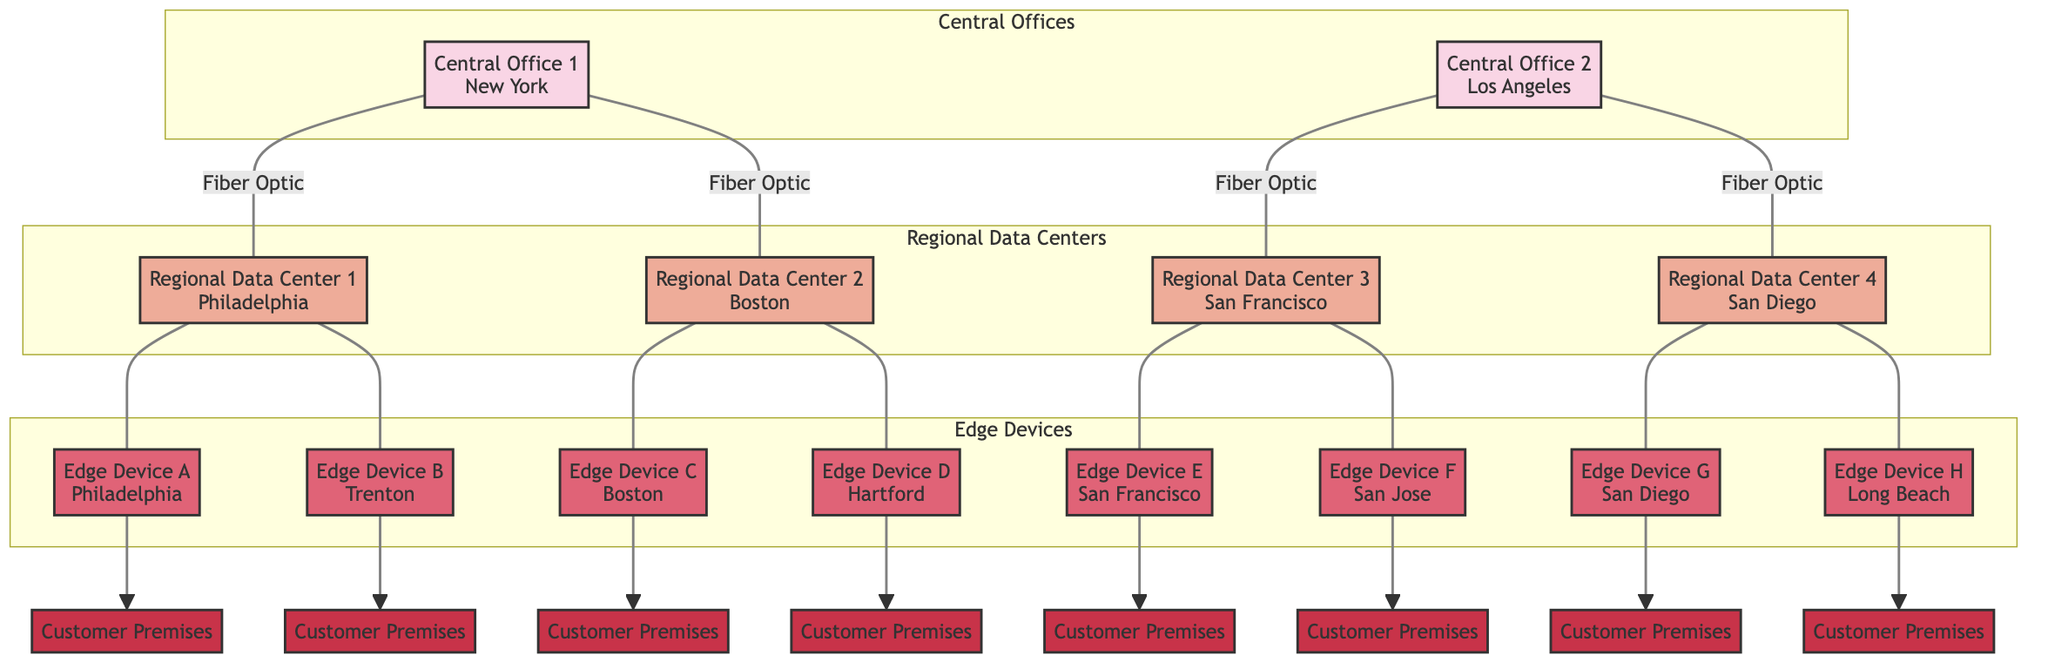What is the role of Central Office 1? According to the diagram, Central Office 1 is defined as the "Main data aggregation and routing hub." This comes directly from the descriptive labels in the nodes.
Answer: Main data aggregation and routing hub How many regional data centers are connected to Central Office 2? By examining the connections from Central Office 2 in the diagram, we see it is linked to two regional data centers: Regional Data Center 3 and Regional Data Center 4. Thus, the count is two.
Answer: 2 Which edge device is located in Boston? The diagram specifies that Edge Device C is in Boston. This information can be found by looking at the location attributes assigned to each edge device in their respective nodes.
Answer: Edge Device C What type of connection is used between Central Office 1 and Regional Data Center 1? The connection type between Central Office 1 and Regional Data Center 1 is labeled as "Fiber Optic" in the diagram, which is noted in the edges connecting the nodes.
Answer: Fiber Optic How many edge devices are connected to Regional Data Center 4? Reviewing the connections, Regional Data Center 4 is connected to two edge devices: Edge Device G and Edge Device H. The count is determined by totaling these connections.
Answer: 2 What is the role of Edge Device A? The diagram states that Edge Device A has the role of "Last mile connectivity." This role is described on the edge device's node directly in the diagram.
Answer: Last mile connectivity How many customer premises are connected to Edge Device F? The diagram indicates that Edge Device F is connected to exactly one customer premises, which is labeled as Customer Premises. The connection is considered singular based on the diagram’s layout.
Answer: 1 Which regional data center is connected to Edge Device D? Edge Device D is connected to Regional Data Center 2, as indicated by the direct connection labeled in the diagram. This is visible in the edges linking the devices together.
Answer: Regional Data Center 2 Which locations are tied to Central Office 2? Central Office 2 connects to Regional Data Center 3 in San Francisco and Regional Data Center 4 in San Diego. The locations can be found by checking each center's node that is connected to Central Office 2.
Answer: San Francisco, San Diego 